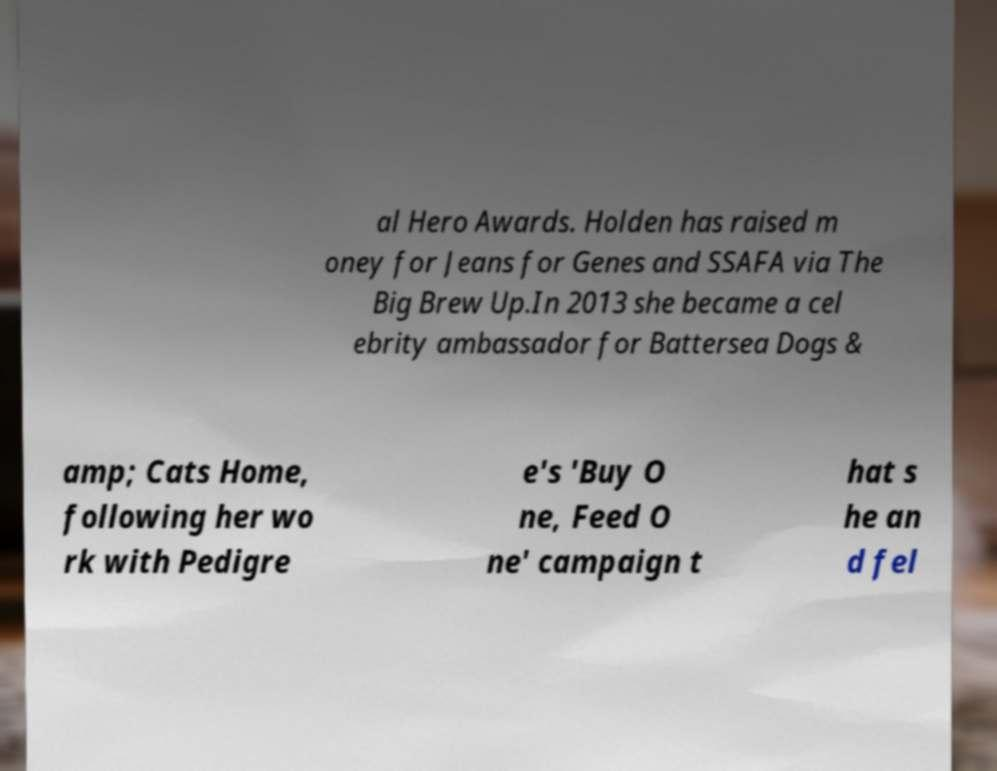For documentation purposes, I need the text within this image transcribed. Could you provide that? al Hero Awards. Holden has raised m oney for Jeans for Genes and SSAFA via The Big Brew Up.In 2013 she became a cel ebrity ambassador for Battersea Dogs & amp; Cats Home, following her wo rk with Pedigre e's 'Buy O ne, Feed O ne' campaign t hat s he an d fel 